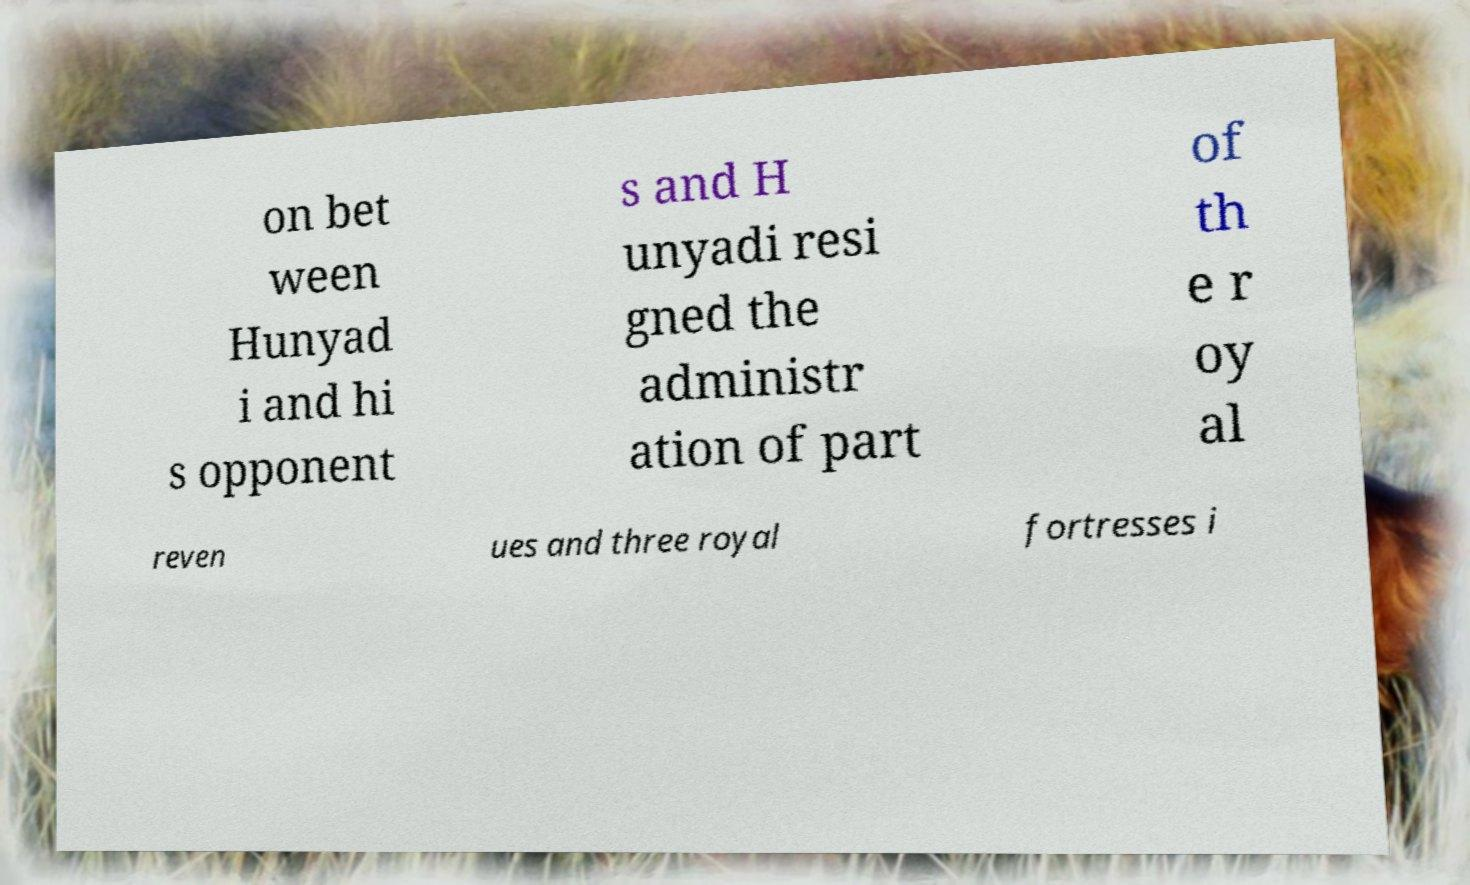Can you read and provide the text displayed in the image?This photo seems to have some interesting text. Can you extract and type it out for me? on bet ween Hunyad i and hi s opponent s and H unyadi resi gned the administr ation of part of th e r oy al reven ues and three royal fortresses i 